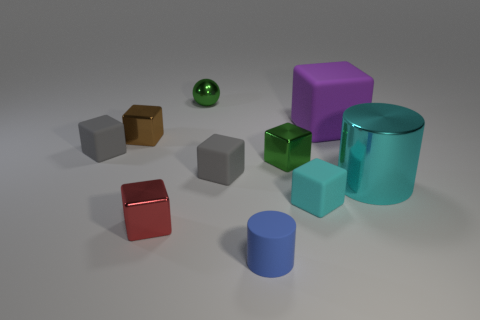Subtract all big purple blocks. How many blocks are left? 6 Subtract all gray cubes. How many cubes are left? 5 Subtract all purple blocks. Subtract all green cylinders. How many blocks are left? 6 Subtract all balls. How many objects are left? 9 Add 5 big purple blocks. How many big purple blocks exist? 6 Subtract 0 yellow cubes. How many objects are left? 10 Subtract all brown metal objects. Subtract all large cyan rubber objects. How many objects are left? 9 Add 5 blue objects. How many blue objects are left? 6 